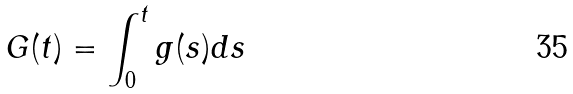Convert formula to latex. <formula><loc_0><loc_0><loc_500><loc_500>G ( t ) = \int _ { 0 } ^ { t } g ( s ) d s</formula> 